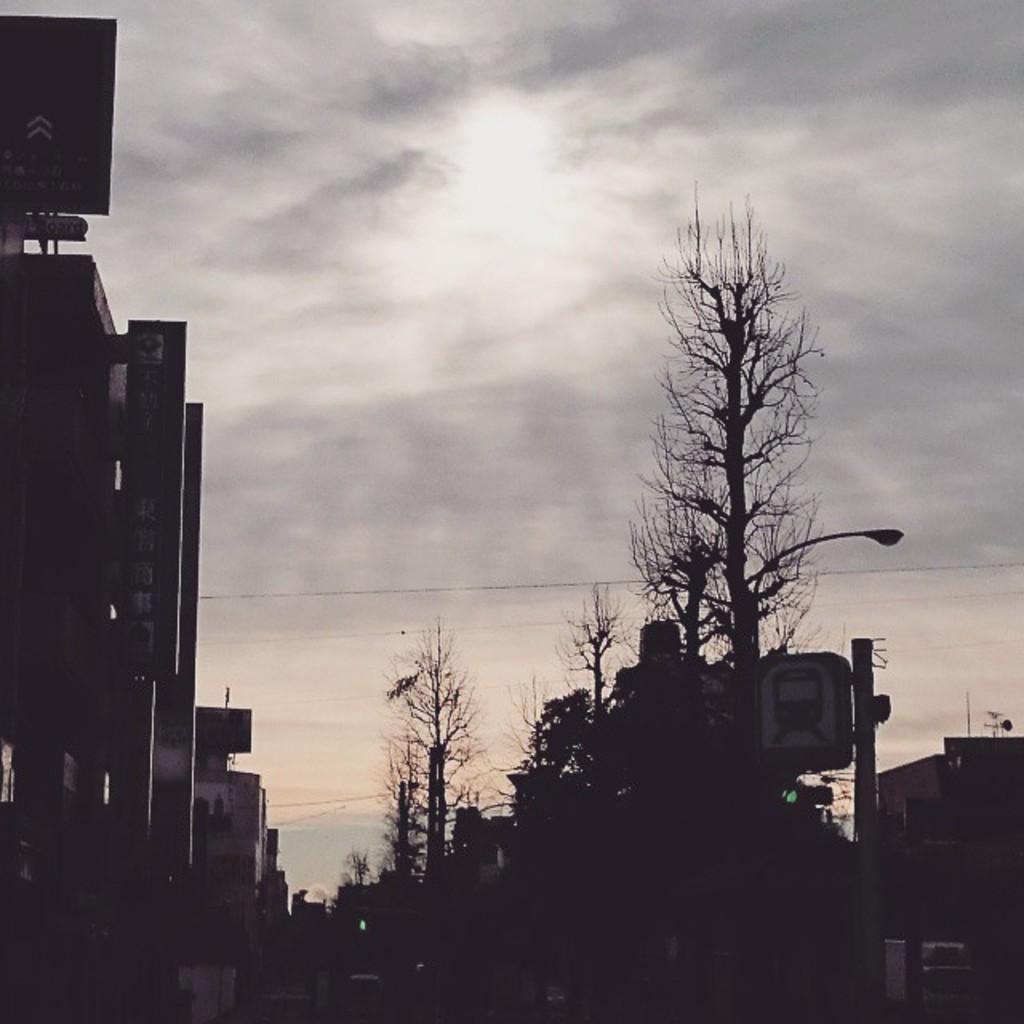Could you give a brief overview of what you see in this image? In this picture I can see buildings, boards, trees, pole, and in the background there is sky. 